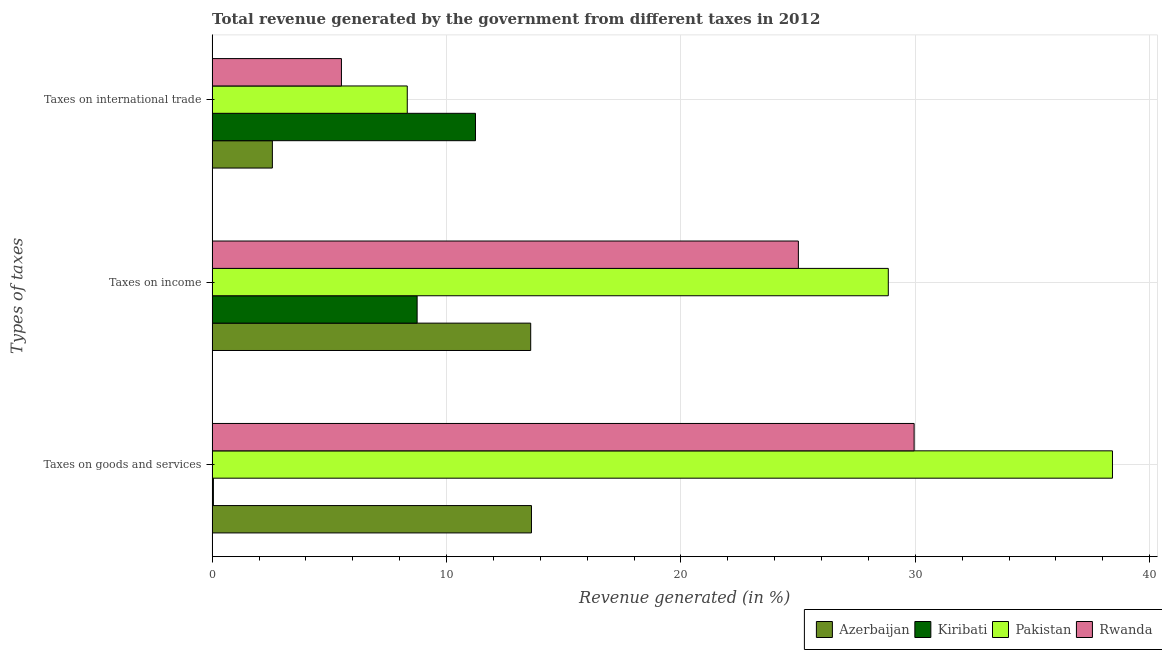How many bars are there on the 2nd tick from the bottom?
Keep it short and to the point. 4. What is the label of the 3rd group of bars from the top?
Your answer should be very brief. Taxes on goods and services. What is the percentage of revenue generated by taxes on goods and services in Pakistan?
Make the answer very short. 38.41. Across all countries, what is the maximum percentage of revenue generated by taxes on income?
Provide a succinct answer. 28.85. Across all countries, what is the minimum percentage of revenue generated by taxes on goods and services?
Provide a succinct answer. 0.05. In which country was the percentage of revenue generated by taxes on goods and services maximum?
Keep it short and to the point. Pakistan. In which country was the percentage of revenue generated by taxes on goods and services minimum?
Offer a very short reply. Kiribati. What is the total percentage of revenue generated by tax on international trade in the graph?
Your answer should be very brief. 27.65. What is the difference between the percentage of revenue generated by tax on international trade in Azerbaijan and that in Kiribati?
Give a very brief answer. -8.67. What is the difference between the percentage of revenue generated by tax on international trade in Kiribati and the percentage of revenue generated by taxes on goods and services in Azerbaijan?
Give a very brief answer. -2.39. What is the average percentage of revenue generated by taxes on goods and services per country?
Your answer should be compact. 20.51. What is the difference between the percentage of revenue generated by taxes on income and percentage of revenue generated by taxes on goods and services in Azerbaijan?
Offer a very short reply. -0.03. What is the ratio of the percentage of revenue generated by taxes on goods and services in Kiribati to that in Azerbaijan?
Offer a terse response. 0. What is the difference between the highest and the second highest percentage of revenue generated by taxes on goods and services?
Your response must be concise. 8.46. What is the difference between the highest and the lowest percentage of revenue generated by taxes on income?
Give a very brief answer. 20.1. In how many countries, is the percentage of revenue generated by taxes on income greater than the average percentage of revenue generated by taxes on income taken over all countries?
Your response must be concise. 2. What does the 3rd bar from the top in Taxes on international trade represents?
Offer a terse response. Kiribati. What does the 3rd bar from the bottom in Taxes on international trade represents?
Keep it short and to the point. Pakistan. How many bars are there?
Provide a succinct answer. 12. Are the values on the major ticks of X-axis written in scientific E-notation?
Give a very brief answer. No. Does the graph contain grids?
Ensure brevity in your answer.  Yes. How many legend labels are there?
Keep it short and to the point. 4. What is the title of the graph?
Offer a very short reply. Total revenue generated by the government from different taxes in 2012. What is the label or title of the X-axis?
Make the answer very short. Revenue generated (in %). What is the label or title of the Y-axis?
Give a very brief answer. Types of taxes. What is the Revenue generated (in %) of Azerbaijan in Taxes on goods and services?
Give a very brief answer. 13.63. What is the Revenue generated (in %) of Kiribati in Taxes on goods and services?
Make the answer very short. 0.05. What is the Revenue generated (in %) in Pakistan in Taxes on goods and services?
Your response must be concise. 38.41. What is the Revenue generated (in %) of Rwanda in Taxes on goods and services?
Give a very brief answer. 29.95. What is the Revenue generated (in %) in Azerbaijan in Taxes on income?
Provide a short and direct response. 13.59. What is the Revenue generated (in %) of Kiribati in Taxes on income?
Provide a succinct answer. 8.75. What is the Revenue generated (in %) in Pakistan in Taxes on income?
Ensure brevity in your answer.  28.85. What is the Revenue generated (in %) in Rwanda in Taxes on income?
Your answer should be very brief. 25.01. What is the Revenue generated (in %) of Azerbaijan in Taxes on international trade?
Make the answer very short. 2.57. What is the Revenue generated (in %) in Kiribati in Taxes on international trade?
Offer a terse response. 11.24. What is the Revenue generated (in %) in Pakistan in Taxes on international trade?
Give a very brief answer. 8.33. What is the Revenue generated (in %) of Rwanda in Taxes on international trade?
Ensure brevity in your answer.  5.52. Across all Types of taxes, what is the maximum Revenue generated (in %) of Azerbaijan?
Ensure brevity in your answer.  13.63. Across all Types of taxes, what is the maximum Revenue generated (in %) in Kiribati?
Your answer should be compact. 11.24. Across all Types of taxes, what is the maximum Revenue generated (in %) in Pakistan?
Keep it short and to the point. 38.41. Across all Types of taxes, what is the maximum Revenue generated (in %) in Rwanda?
Your answer should be very brief. 29.95. Across all Types of taxes, what is the minimum Revenue generated (in %) of Azerbaijan?
Your answer should be very brief. 2.57. Across all Types of taxes, what is the minimum Revenue generated (in %) of Kiribati?
Provide a short and direct response. 0.05. Across all Types of taxes, what is the minimum Revenue generated (in %) in Pakistan?
Offer a very short reply. 8.33. Across all Types of taxes, what is the minimum Revenue generated (in %) in Rwanda?
Keep it short and to the point. 5.52. What is the total Revenue generated (in %) of Azerbaijan in the graph?
Keep it short and to the point. 29.79. What is the total Revenue generated (in %) in Kiribati in the graph?
Offer a terse response. 20.04. What is the total Revenue generated (in %) of Pakistan in the graph?
Give a very brief answer. 75.59. What is the total Revenue generated (in %) of Rwanda in the graph?
Make the answer very short. 60.48. What is the difference between the Revenue generated (in %) of Azerbaijan in Taxes on goods and services and that in Taxes on income?
Your response must be concise. 0.03. What is the difference between the Revenue generated (in %) in Kiribati in Taxes on goods and services and that in Taxes on income?
Offer a terse response. -8.69. What is the difference between the Revenue generated (in %) in Pakistan in Taxes on goods and services and that in Taxes on income?
Your answer should be compact. 9.56. What is the difference between the Revenue generated (in %) in Rwanda in Taxes on goods and services and that in Taxes on income?
Offer a terse response. 4.94. What is the difference between the Revenue generated (in %) in Azerbaijan in Taxes on goods and services and that in Taxes on international trade?
Offer a very short reply. 11.05. What is the difference between the Revenue generated (in %) of Kiribati in Taxes on goods and services and that in Taxes on international trade?
Give a very brief answer. -11.18. What is the difference between the Revenue generated (in %) of Pakistan in Taxes on goods and services and that in Taxes on international trade?
Provide a short and direct response. 30.09. What is the difference between the Revenue generated (in %) in Rwanda in Taxes on goods and services and that in Taxes on international trade?
Make the answer very short. 24.43. What is the difference between the Revenue generated (in %) of Azerbaijan in Taxes on income and that in Taxes on international trade?
Provide a short and direct response. 11.02. What is the difference between the Revenue generated (in %) of Kiribati in Taxes on income and that in Taxes on international trade?
Give a very brief answer. -2.49. What is the difference between the Revenue generated (in %) of Pakistan in Taxes on income and that in Taxes on international trade?
Your answer should be compact. 20.52. What is the difference between the Revenue generated (in %) of Rwanda in Taxes on income and that in Taxes on international trade?
Provide a succinct answer. 19.5. What is the difference between the Revenue generated (in %) in Azerbaijan in Taxes on goods and services and the Revenue generated (in %) in Kiribati in Taxes on income?
Your response must be concise. 4.88. What is the difference between the Revenue generated (in %) of Azerbaijan in Taxes on goods and services and the Revenue generated (in %) of Pakistan in Taxes on income?
Your answer should be compact. -15.22. What is the difference between the Revenue generated (in %) of Azerbaijan in Taxes on goods and services and the Revenue generated (in %) of Rwanda in Taxes on income?
Your answer should be very brief. -11.39. What is the difference between the Revenue generated (in %) in Kiribati in Taxes on goods and services and the Revenue generated (in %) in Pakistan in Taxes on income?
Your response must be concise. -28.8. What is the difference between the Revenue generated (in %) in Kiribati in Taxes on goods and services and the Revenue generated (in %) in Rwanda in Taxes on income?
Provide a succinct answer. -24.96. What is the difference between the Revenue generated (in %) of Pakistan in Taxes on goods and services and the Revenue generated (in %) of Rwanda in Taxes on income?
Make the answer very short. 13.4. What is the difference between the Revenue generated (in %) of Azerbaijan in Taxes on goods and services and the Revenue generated (in %) of Kiribati in Taxes on international trade?
Provide a succinct answer. 2.39. What is the difference between the Revenue generated (in %) of Azerbaijan in Taxes on goods and services and the Revenue generated (in %) of Pakistan in Taxes on international trade?
Ensure brevity in your answer.  5.3. What is the difference between the Revenue generated (in %) in Azerbaijan in Taxes on goods and services and the Revenue generated (in %) in Rwanda in Taxes on international trade?
Offer a very short reply. 8.11. What is the difference between the Revenue generated (in %) of Kiribati in Taxes on goods and services and the Revenue generated (in %) of Pakistan in Taxes on international trade?
Your answer should be very brief. -8.27. What is the difference between the Revenue generated (in %) in Kiribati in Taxes on goods and services and the Revenue generated (in %) in Rwanda in Taxes on international trade?
Ensure brevity in your answer.  -5.46. What is the difference between the Revenue generated (in %) of Pakistan in Taxes on goods and services and the Revenue generated (in %) of Rwanda in Taxes on international trade?
Your answer should be compact. 32.9. What is the difference between the Revenue generated (in %) of Azerbaijan in Taxes on income and the Revenue generated (in %) of Kiribati in Taxes on international trade?
Offer a very short reply. 2.36. What is the difference between the Revenue generated (in %) in Azerbaijan in Taxes on income and the Revenue generated (in %) in Pakistan in Taxes on international trade?
Ensure brevity in your answer.  5.27. What is the difference between the Revenue generated (in %) of Azerbaijan in Taxes on income and the Revenue generated (in %) of Rwanda in Taxes on international trade?
Your answer should be compact. 8.07. What is the difference between the Revenue generated (in %) of Kiribati in Taxes on income and the Revenue generated (in %) of Pakistan in Taxes on international trade?
Ensure brevity in your answer.  0.42. What is the difference between the Revenue generated (in %) in Kiribati in Taxes on income and the Revenue generated (in %) in Rwanda in Taxes on international trade?
Provide a short and direct response. 3.23. What is the difference between the Revenue generated (in %) of Pakistan in Taxes on income and the Revenue generated (in %) of Rwanda in Taxes on international trade?
Your answer should be very brief. 23.33. What is the average Revenue generated (in %) in Azerbaijan per Types of taxes?
Provide a short and direct response. 9.93. What is the average Revenue generated (in %) in Kiribati per Types of taxes?
Offer a terse response. 6.68. What is the average Revenue generated (in %) in Pakistan per Types of taxes?
Offer a terse response. 25.2. What is the average Revenue generated (in %) in Rwanda per Types of taxes?
Ensure brevity in your answer.  20.16. What is the difference between the Revenue generated (in %) of Azerbaijan and Revenue generated (in %) of Kiribati in Taxes on goods and services?
Provide a succinct answer. 13.57. What is the difference between the Revenue generated (in %) in Azerbaijan and Revenue generated (in %) in Pakistan in Taxes on goods and services?
Ensure brevity in your answer.  -24.79. What is the difference between the Revenue generated (in %) in Azerbaijan and Revenue generated (in %) in Rwanda in Taxes on goods and services?
Your answer should be compact. -16.33. What is the difference between the Revenue generated (in %) of Kiribati and Revenue generated (in %) of Pakistan in Taxes on goods and services?
Your answer should be compact. -38.36. What is the difference between the Revenue generated (in %) in Kiribati and Revenue generated (in %) in Rwanda in Taxes on goods and services?
Provide a succinct answer. -29.9. What is the difference between the Revenue generated (in %) in Pakistan and Revenue generated (in %) in Rwanda in Taxes on goods and services?
Offer a terse response. 8.46. What is the difference between the Revenue generated (in %) in Azerbaijan and Revenue generated (in %) in Kiribati in Taxes on income?
Offer a terse response. 4.85. What is the difference between the Revenue generated (in %) in Azerbaijan and Revenue generated (in %) in Pakistan in Taxes on income?
Provide a succinct answer. -15.26. What is the difference between the Revenue generated (in %) of Azerbaijan and Revenue generated (in %) of Rwanda in Taxes on income?
Keep it short and to the point. -11.42. What is the difference between the Revenue generated (in %) in Kiribati and Revenue generated (in %) in Pakistan in Taxes on income?
Offer a terse response. -20.1. What is the difference between the Revenue generated (in %) in Kiribati and Revenue generated (in %) in Rwanda in Taxes on income?
Your response must be concise. -16.27. What is the difference between the Revenue generated (in %) of Pakistan and Revenue generated (in %) of Rwanda in Taxes on income?
Ensure brevity in your answer.  3.84. What is the difference between the Revenue generated (in %) of Azerbaijan and Revenue generated (in %) of Kiribati in Taxes on international trade?
Offer a terse response. -8.67. What is the difference between the Revenue generated (in %) in Azerbaijan and Revenue generated (in %) in Pakistan in Taxes on international trade?
Offer a very short reply. -5.76. What is the difference between the Revenue generated (in %) of Azerbaijan and Revenue generated (in %) of Rwanda in Taxes on international trade?
Your response must be concise. -2.95. What is the difference between the Revenue generated (in %) in Kiribati and Revenue generated (in %) in Pakistan in Taxes on international trade?
Your answer should be compact. 2.91. What is the difference between the Revenue generated (in %) in Kiribati and Revenue generated (in %) in Rwanda in Taxes on international trade?
Give a very brief answer. 5.72. What is the difference between the Revenue generated (in %) in Pakistan and Revenue generated (in %) in Rwanda in Taxes on international trade?
Your response must be concise. 2.81. What is the ratio of the Revenue generated (in %) of Azerbaijan in Taxes on goods and services to that in Taxes on income?
Offer a very short reply. 1. What is the ratio of the Revenue generated (in %) of Kiribati in Taxes on goods and services to that in Taxes on income?
Your answer should be very brief. 0.01. What is the ratio of the Revenue generated (in %) in Pakistan in Taxes on goods and services to that in Taxes on income?
Your response must be concise. 1.33. What is the ratio of the Revenue generated (in %) in Rwanda in Taxes on goods and services to that in Taxes on income?
Keep it short and to the point. 1.2. What is the ratio of the Revenue generated (in %) of Azerbaijan in Taxes on goods and services to that in Taxes on international trade?
Provide a succinct answer. 5.3. What is the ratio of the Revenue generated (in %) of Kiribati in Taxes on goods and services to that in Taxes on international trade?
Ensure brevity in your answer.  0. What is the ratio of the Revenue generated (in %) in Pakistan in Taxes on goods and services to that in Taxes on international trade?
Your answer should be very brief. 4.61. What is the ratio of the Revenue generated (in %) in Rwanda in Taxes on goods and services to that in Taxes on international trade?
Your answer should be compact. 5.43. What is the ratio of the Revenue generated (in %) of Azerbaijan in Taxes on income to that in Taxes on international trade?
Your answer should be very brief. 5.29. What is the ratio of the Revenue generated (in %) of Kiribati in Taxes on income to that in Taxes on international trade?
Offer a terse response. 0.78. What is the ratio of the Revenue generated (in %) in Pakistan in Taxes on income to that in Taxes on international trade?
Provide a short and direct response. 3.47. What is the ratio of the Revenue generated (in %) of Rwanda in Taxes on income to that in Taxes on international trade?
Your answer should be very brief. 4.53. What is the difference between the highest and the second highest Revenue generated (in %) of Azerbaijan?
Offer a very short reply. 0.03. What is the difference between the highest and the second highest Revenue generated (in %) of Kiribati?
Offer a terse response. 2.49. What is the difference between the highest and the second highest Revenue generated (in %) in Pakistan?
Your response must be concise. 9.56. What is the difference between the highest and the second highest Revenue generated (in %) in Rwanda?
Give a very brief answer. 4.94. What is the difference between the highest and the lowest Revenue generated (in %) in Azerbaijan?
Provide a succinct answer. 11.05. What is the difference between the highest and the lowest Revenue generated (in %) in Kiribati?
Offer a very short reply. 11.18. What is the difference between the highest and the lowest Revenue generated (in %) of Pakistan?
Your response must be concise. 30.09. What is the difference between the highest and the lowest Revenue generated (in %) in Rwanda?
Your response must be concise. 24.43. 